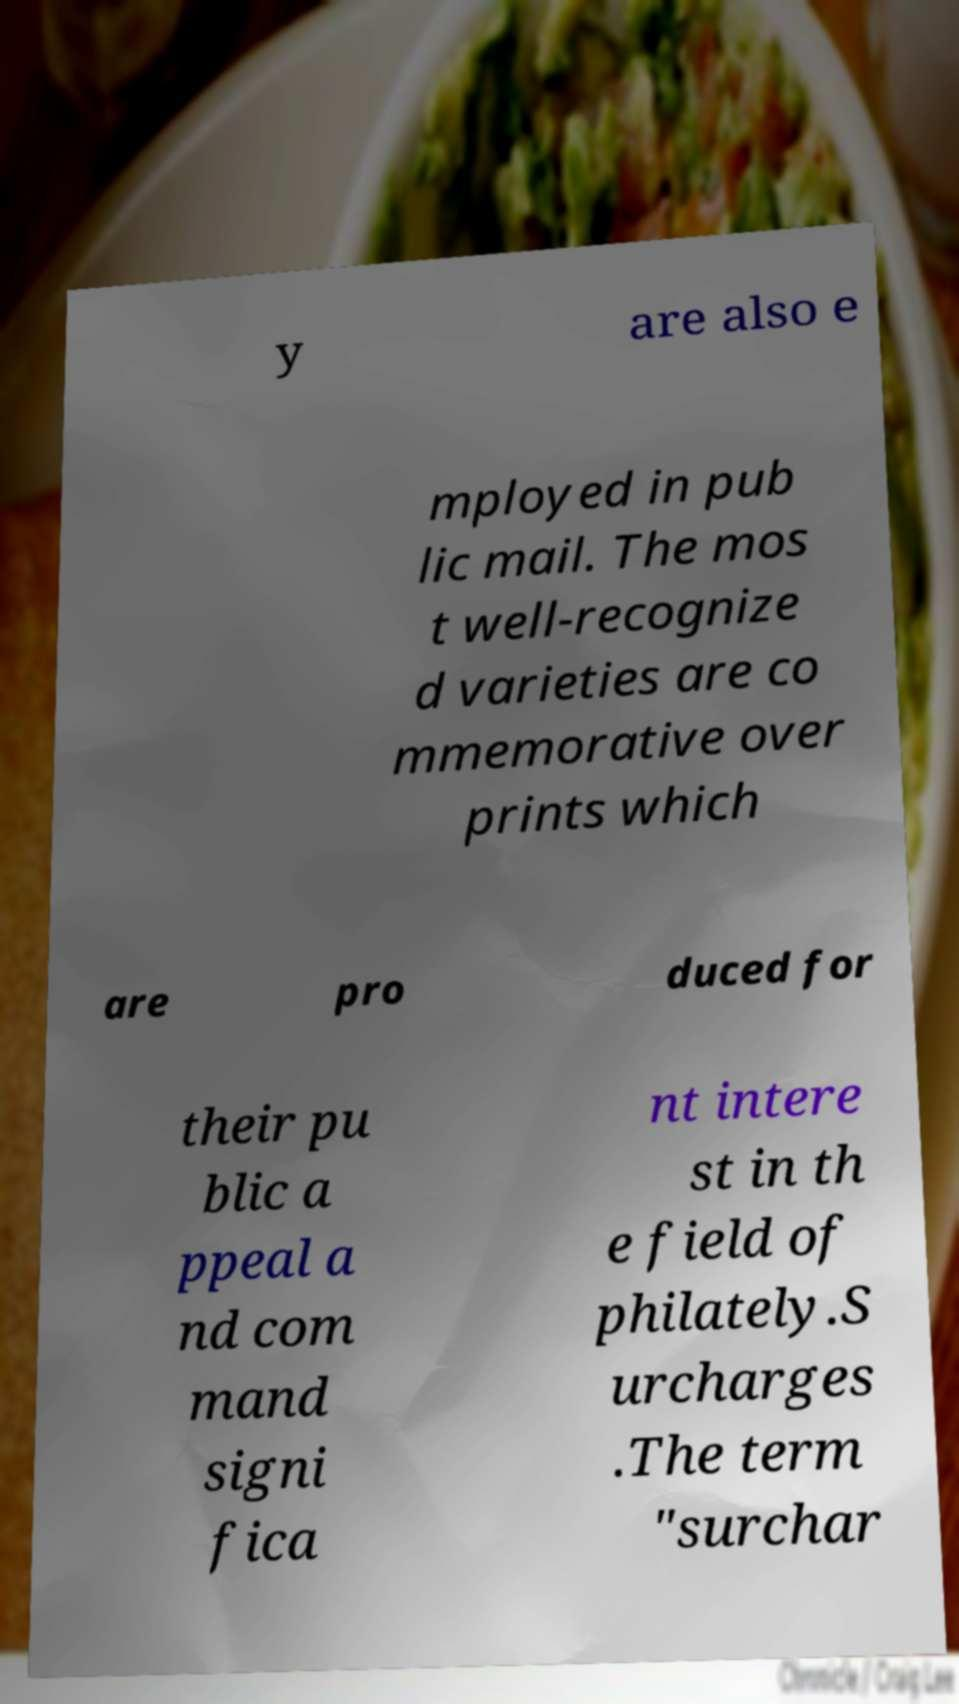For documentation purposes, I need the text within this image transcribed. Could you provide that? y are also e mployed in pub lic mail. The mos t well-recognize d varieties are co mmemorative over prints which are pro duced for their pu blic a ppeal a nd com mand signi fica nt intere st in th e field of philately.S urcharges .The term "surchar 